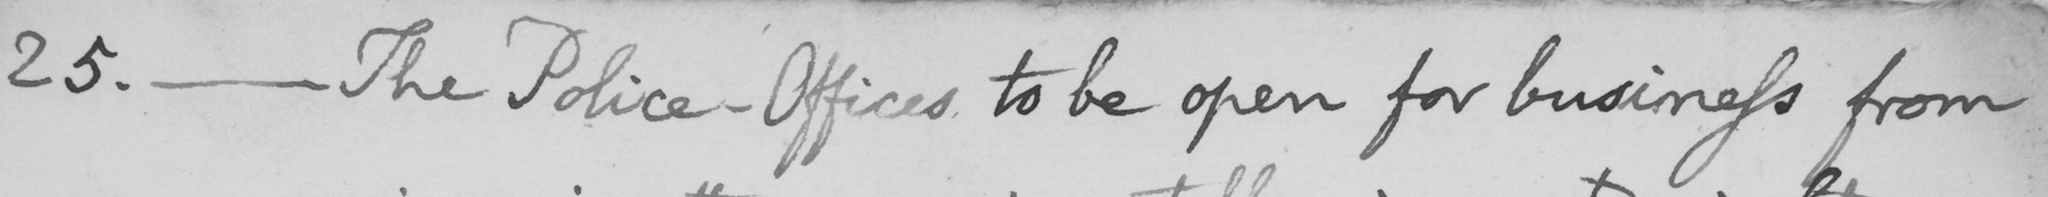Transcribe the text shown in this historical manuscript line. 25. _ The Police-Offices to be open for business from 